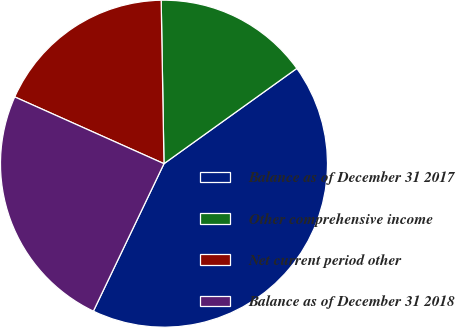Convert chart. <chart><loc_0><loc_0><loc_500><loc_500><pie_chart><fcel>Balance as of December 31 2017<fcel>Other comprehensive income<fcel>Net current period other<fcel>Balance as of December 31 2018<nl><fcel>42.01%<fcel>15.37%<fcel>18.03%<fcel>24.59%<nl></chart> 